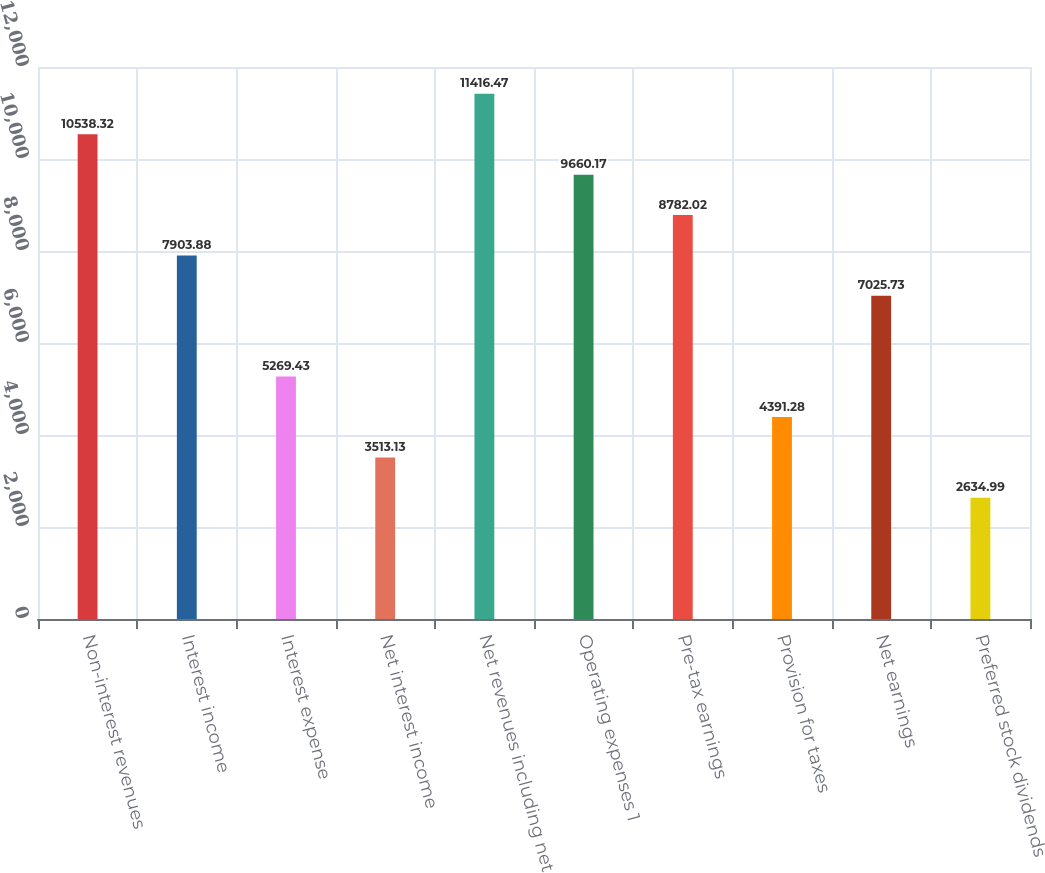Convert chart to OTSL. <chart><loc_0><loc_0><loc_500><loc_500><bar_chart><fcel>Non-interest revenues<fcel>Interest income<fcel>Interest expense<fcel>Net interest income<fcel>Net revenues including net<fcel>Operating expenses 1<fcel>Pre-tax earnings<fcel>Provision for taxes<fcel>Net earnings<fcel>Preferred stock dividends<nl><fcel>10538.3<fcel>7903.88<fcel>5269.43<fcel>3513.13<fcel>11416.5<fcel>9660.17<fcel>8782.02<fcel>4391.28<fcel>7025.73<fcel>2634.99<nl></chart> 